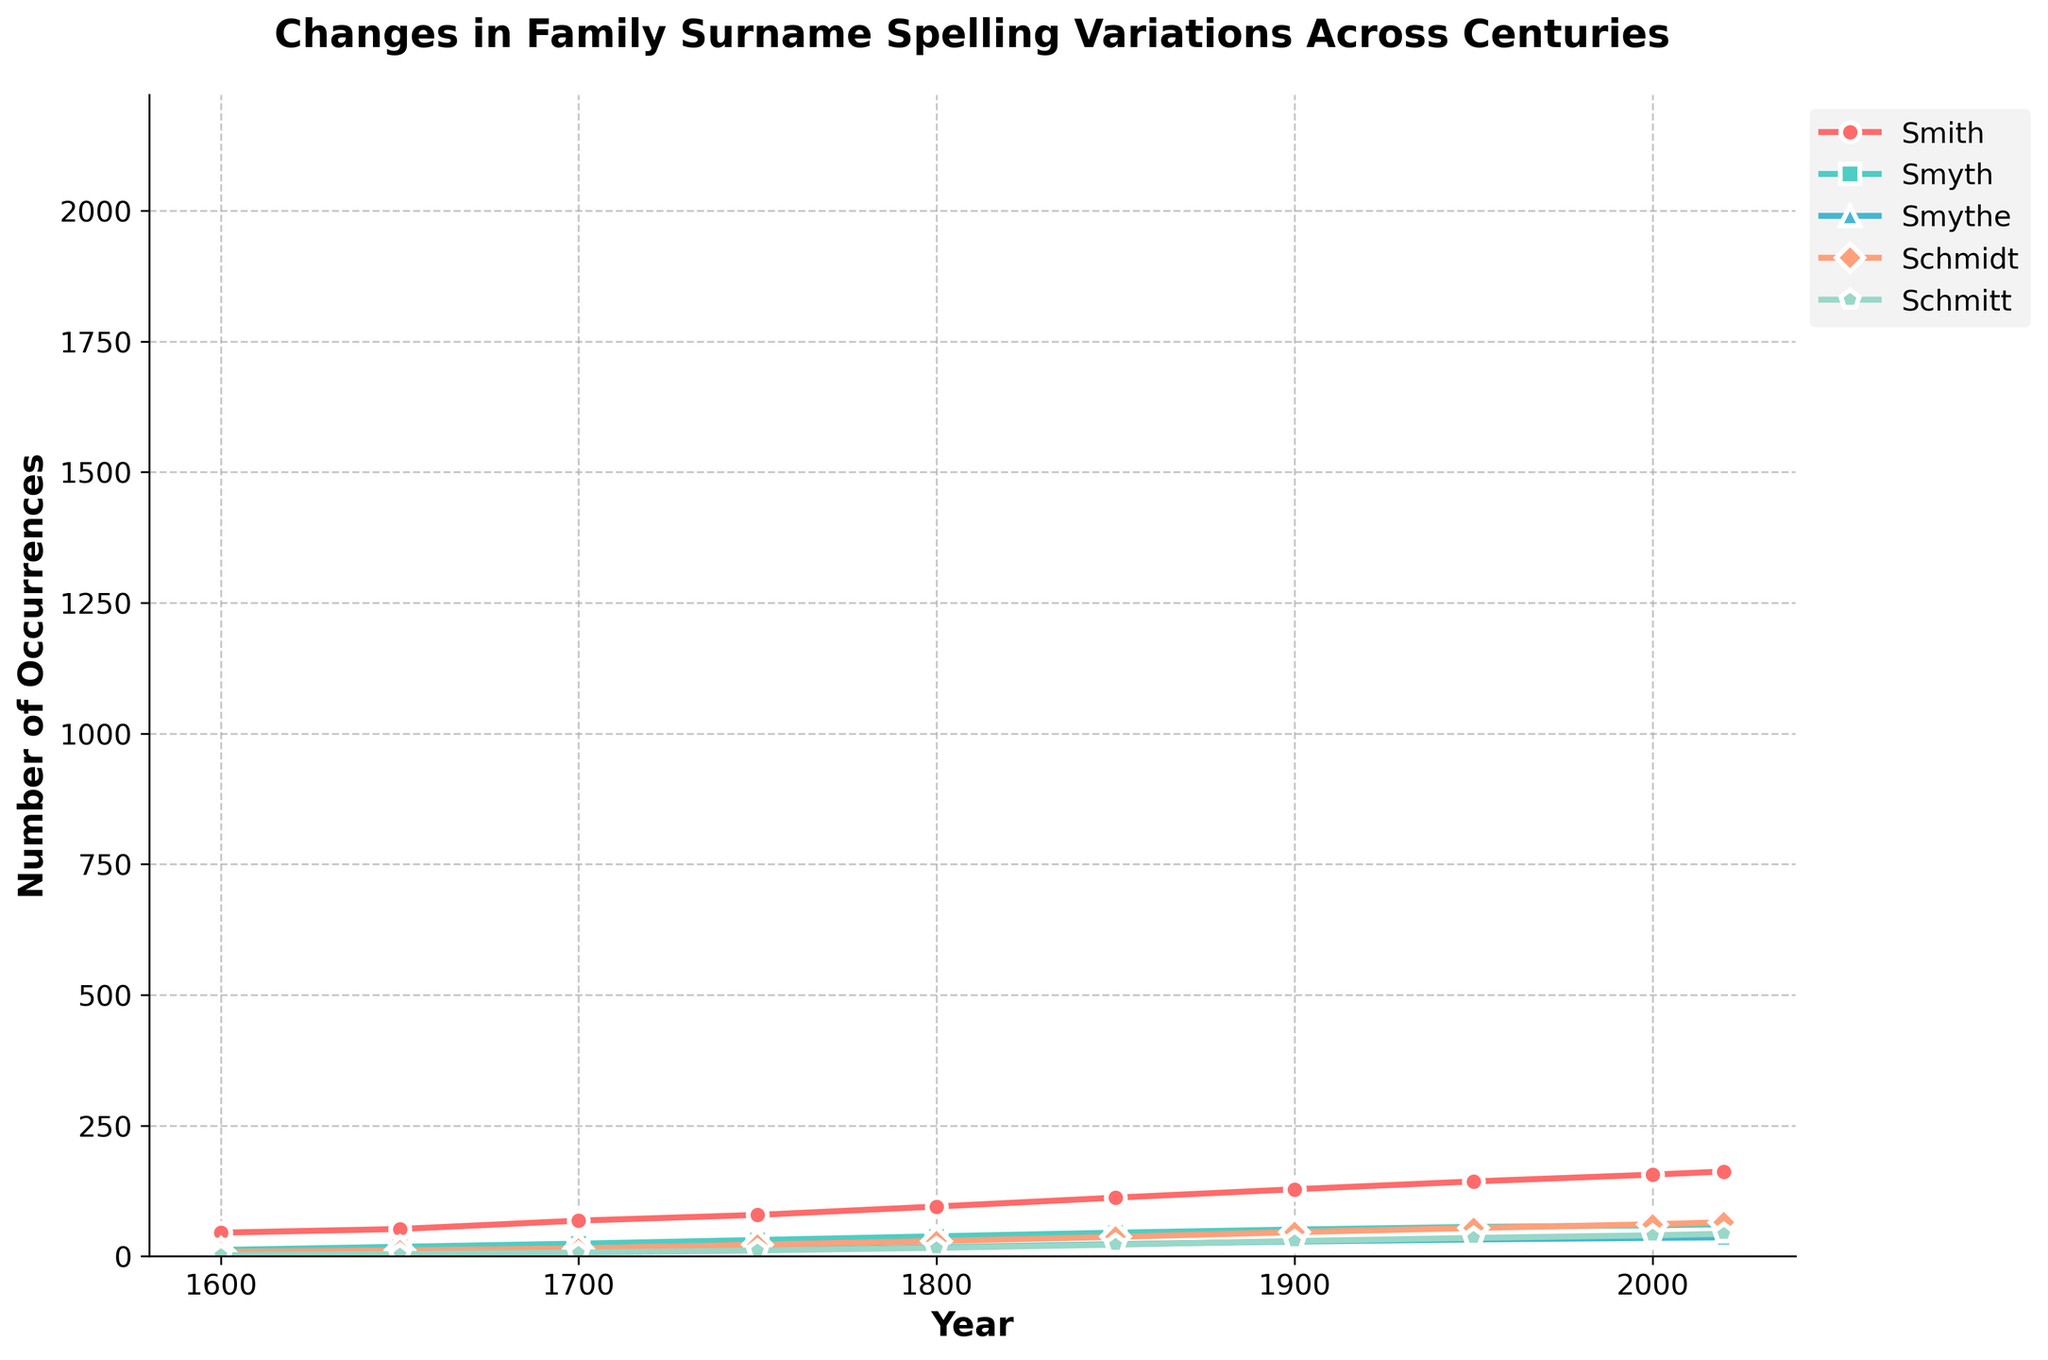What is the occurrence of the surname "Smith" in 2000 and 2020? In 2000, the occurrence of "Smith" is 156, and in 2020, it is 162. These values can be directly read from the plot where the "Smith" line intersects the years 2000 and 2020 on the x-axis.
Answer: 156 and 162 Between which two consecutive centuries did the surname "Schmidt" see the greatest increase? The greatest increase in the surname "Schmidt" occurs between 1900 and 1950, rising from 46 to 54. The increase is calculated as 54 - 46 = 8. This can be seen by comparing the steepness of the "Schmidt" line segments between different time periods.
Answer: 1900 and 1950 What is the difference in occurrences between the surnames "Smyth" and "Smythe" in 1650? In 1650, "Smyth" has 18 occurrences and "Smythe" has 5 occurrences. The difference is calculated as 18 - 5 = 13. These values can be directly read from where the "Smyth" and "Smythe" lines intersect the year 1650 on the x-axis.
Answer: 13 Which surname shows the least variation in occurrences across all years? The surname "Schmitt" shows the least variation in occurrences. This is determined by observing that "Schmitt" has the smallest range between its lowest value (2 in 1600) and highest value (43 in 2020) compared to other surnames' ranges.
Answer: Schmitt What is the average occurrence of the surname "Smythe" across all years? The occurrences of "Smythe" across all years are [3, 5, 8, 12, 17, 23, 28, 32, 35, 36]. Sum these values to get 199. The average is 199/10 = 19.9.
Answer: 19.9 In which year did the surname "Smith" have its highest occurrence, and what was the value? "Smith" had its highest occurrence in 2020, with 162 occurrences. This is determined by finding the peak point on the "Smith" line in the plot.
Answer: 2020, 162 How much did the occurrence of "Schmitt" increase from 1600 to 2020? The occurrence of "Schmitt" in 1600 is 2 and in 2020 is 43. The increase is calculated as 43 - 2 = 41. These values can be directly read from the plot.
Answer: 41 Which surname had the second highest occurrence in 1800, and what is that value? In 1800, the surname "Smyth" had the second highest occurrence with a value of 38. This can be determined by comparing the values at the year 1800 and observing that "Smith" is highest, followed by "Smyth."
Answer: Smyth, 38 